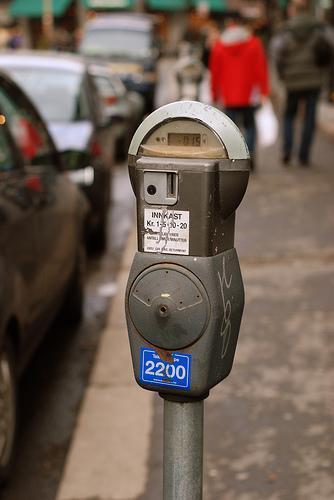How many blue stickers are on the meter?
Give a very brief answer. 1. 